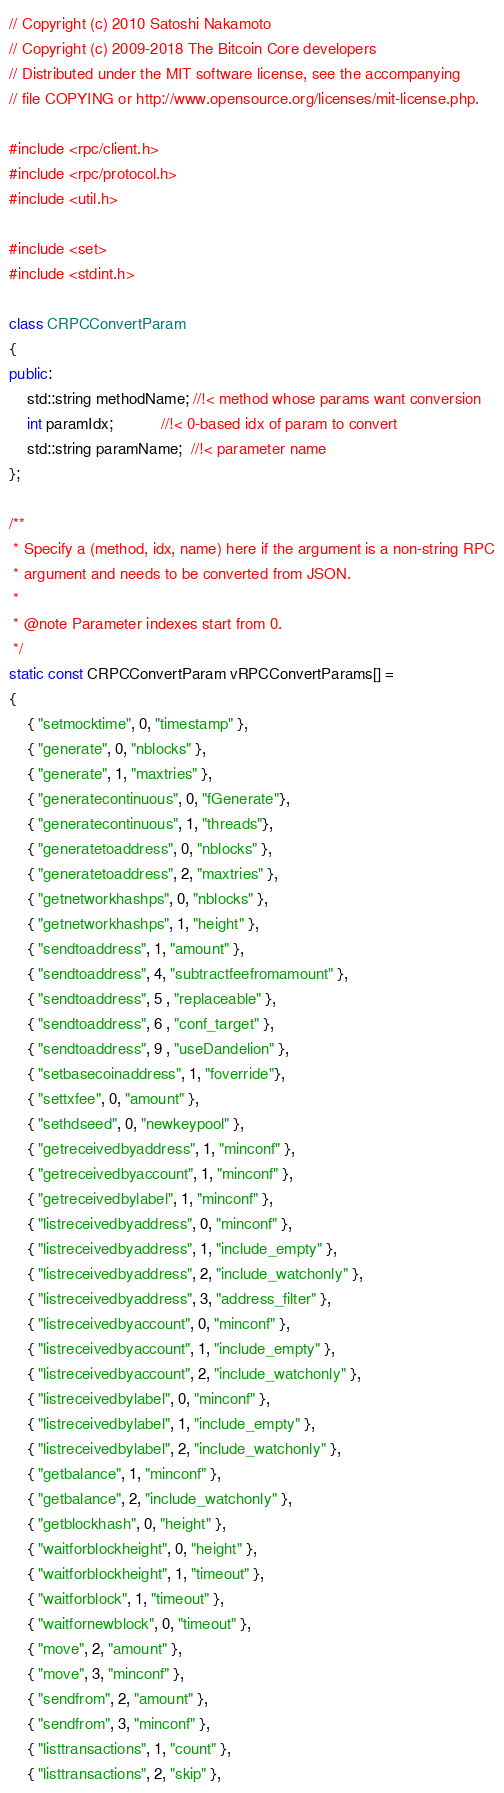<code> <loc_0><loc_0><loc_500><loc_500><_C++_>// Copyright (c) 2010 Satoshi Nakamoto
// Copyright (c) 2009-2018 The Bitcoin Core developers
// Distributed under the MIT software license, see the accompanying
// file COPYING or http://www.opensource.org/licenses/mit-license.php.

#include <rpc/client.h>
#include <rpc/protocol.h>
#include <util.h>

#include <set>
#include <stdint.h>

class CRPCConvertParam
{
public:
    std::string methodName; //!< method whose params want conversion
    int paramIdx;           //!< 0-based idx of param to convert
    std::string paramName;  //!< parameter name
};

/**
 * Specify a (method, idx, name) here if the argument is a non-string RPC
 * argument and needs to be converted from JSON.
 *
 * @note Parameter indexes start from 0.
 */
static const CRPCConvertParam vRPCConvertParams[] =
{
    { "setmocktime", 0, "timestamp" },
    { "generate", 0, "nblocks" },
    { "generate", 1, "maxtries" },
    { "generatecontinuous", 0, "fGenerate"},
    { "generatecontinuous", 1, "threads"},
    { "generatetoaddress", 0, "nblocks" },
    { "generatetoaddress", 2, "maxtries" },
    { "getnetworkhashps", 0, "nblocks" },
    { "getnetworkhashps", 1, "height" },
    { "sendtoaddress", 1, "amount" },
    { "sendtoaddress", 4, "subtractfeefromamount" },
    { "sendtoaddress", 5 , "replaceable" },
    { "sendtoaddress", 6 , "conf_target" },
    { "sendtoaddress", 9 , "useDandelion" },
    { "setbasecoinaddress", 1, "foverride"},
    { "settxfee", 0, "amount" },
    { "sethdseed", 0, "newkeypool" },
    { "getreceivedbyaddress", 1, "minconf" },
    { "getreceivedbyaccount", 1, "minconf" },
    { "getreceivedbylabel", 1, "minconf" },
    { "listreceivedbyaddress", 0, "minconf" },
    { "listreceivedbyaddress", 1, "include_empty" },
    { "listreceivedbyaddress", 2, "include_watchonly" },
    { "listreceivedbyaddress", 3, "address_filter" },
    { "listreceivedbyaccount", 0, "minconf" },
    { "listreceivedbyaccount", 1, "include_empty" },
    { "listreceivedbyaccount", 2, "include_watchonly" },
    { "listreceivedbylabel", 0, "minconf" },
    { "listreceivedbylabel", 1, "include_empty" },
    { "listreceivedbylabel", 2, "include_watchonly" },
    { "getbalance", 1, "minconf" },
    { "getbalance", 2, "include_watchonly" },
    { "getblockhash", 0, "height" },
    { "waitforblockheight", 0, "height" },
    { "waitforblockheight", 1, "timeout" },
    { "waitforblock", 1, "timeout" },
    { "waitfornewblock", 0, "timeout" },
    { "move", 2, "amount" },
    { "move", 3, "minconf" },
    { "sendfrom", 2, "amount" },
    { "sendfrom", 3, "minconf" },
    { "listtransactions", 1, "count" },
    { "listtransactions", 2, "skip" },</code> 